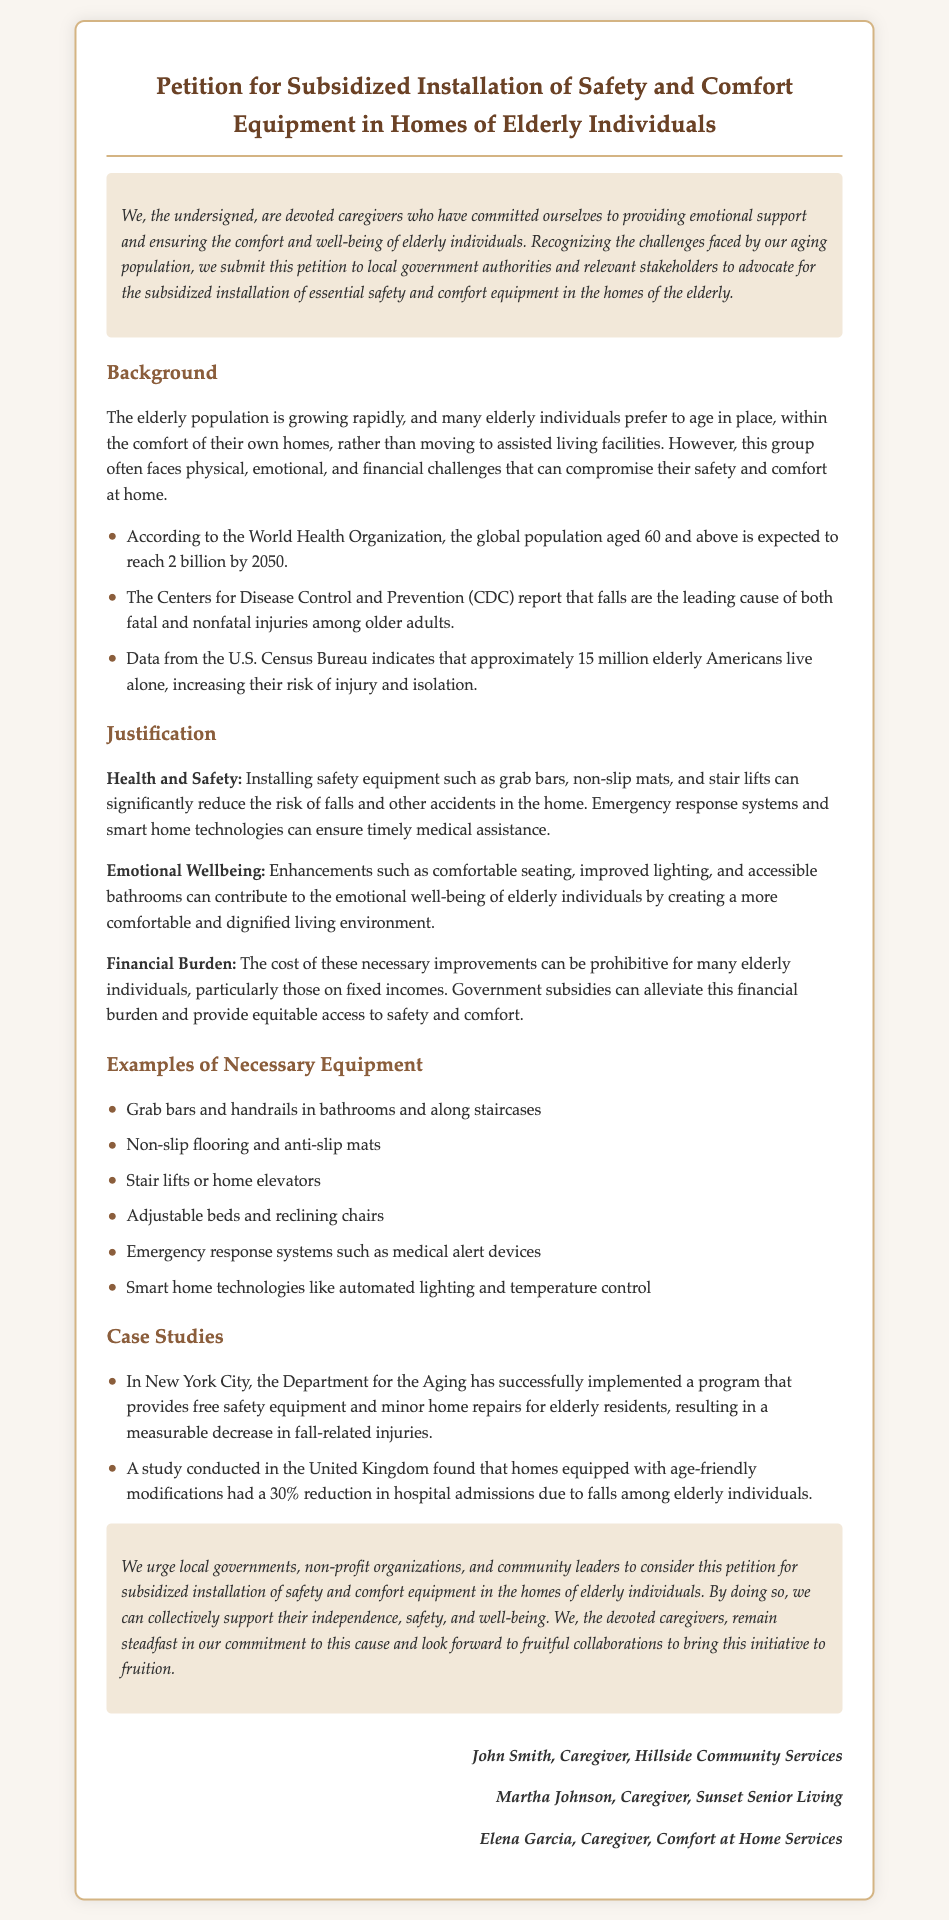What is the title of the petition? The title summarizes the purpose of the document, which is the proposal for specific installations to aid the elderly.
Answer: Petition for Subsidized Installation of Safety and Comfort Equipment in Homes of Elderly Individuals Who are the signers of the petition? The document lists individuals who support the petition, identifying their roles and affiliations.
Answer: John Smith, Martha Johnson, Elena Garcia What are the leading causes of injuries among older adults? The petition references data from the CDC regarding risks faced by the elderly, specifically related to their environment.
Answer: Falls How many elderly Americans live alone according to the U.S. Census Bureau? The document cites statistics from the U.S. Census Bureau about the living situations of the elderly population.
Answer: Approximately 15 million What type of modifications can reduce hospital admissions due to falls? The petition refers to a study indicating specific changes in the home environment that improve safety.
Answer: Age-friendly modifications What is one example of necessary equipment mentioned in the petition? The petition provides a list of items crucial for safety and comfort improvements in elderly homes.
Answer: Grab bars and handrails What organization successfully implemented a safety equipment program in New York City? The petition provides a specific case study related to the implementation of safety measures for the elderly.
Answer: Department for the Aging Why is financial burden mentioned in the justification section? The document discusses the challenges elderly individuals face regarding the costs of safety equipment.
Answer: To alleviate this financial burden 